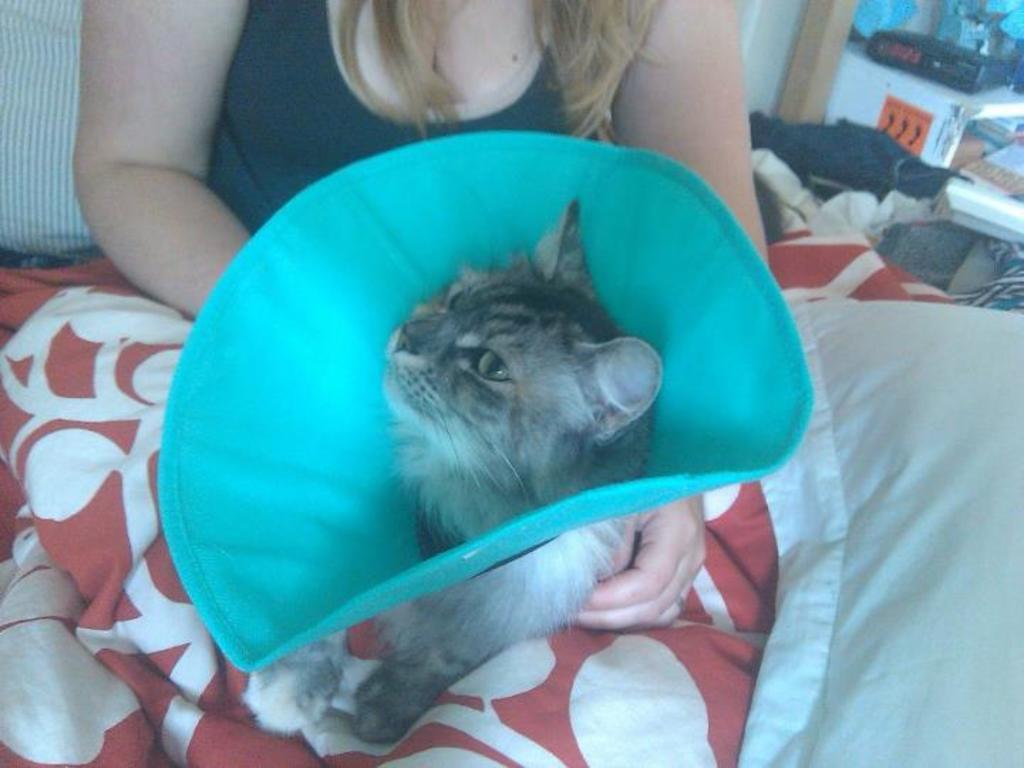Could you give a brief overview of what you see in this image? in this image i can see a cat. behind her there is a person in black dress. at the right side there is a pillow. 